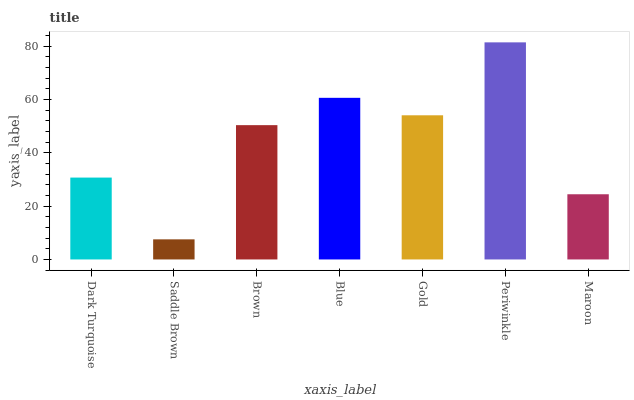Is Saddle Brown the minimum?
Answer yes or no. Yes. Is Periwinkle the maximum?
Answer yes or no. Yes. Is Brown the minimum?
Answer yes or no. No. Is Brown the maximum?
Answer yes or no. No. Is Brown greater than Saddle Brown?
Answer yes or no. Yes. Is Saddle Brown less than Brown?
Answer yes or no. Yes. Is Saddle Brown greater than Brown?
Answer yes or no. No. Is Brown less than Saddle Brown?
Answer yes or no. No. Is Brown the high median?
Answer yes or no. Yes. Is Brown the low median?
Answer yes or no. Yes. Is Gold the high median?
Answer yes or no. No. Is Saddle Brown the low median?
Answer yes or no. No. 